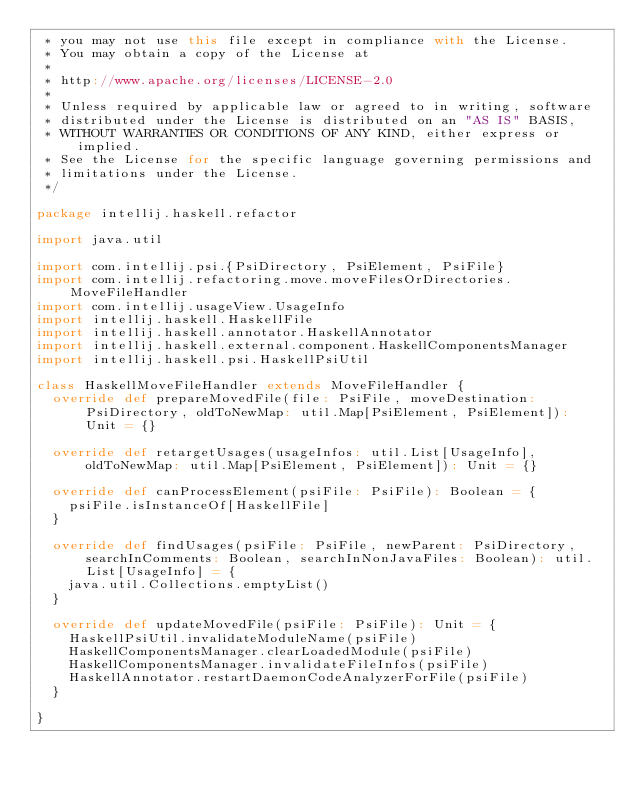<code> <loc_0><loc_0><loc_500><loc_500><_Scala_> * you may not use this file except in compliance with the License.
 * You may obtain a copy of the License at
 *
 * http://www.apache.org/licenses/LICENSE-2.0
 *
 * Unless required by applicable law or agreed to in writing, software
 * distributed under the License is distributed on an "AS IS" BASIS,
 * WITHOUT WARRANTIES OR CONDITIONS OF ANY KIND, either express or implied.
 * See the License for the specific language governing permissions and
 * limitations under the License.
 */

package intellij.haskell.refactor

import java.util

import com.intellij.psi.{PsiDirectory, PsiElement, PsiFile}
import com.intellij.refactoring.move.moveFilesOrDirectories.MoveFileHandler
import com.intellij.usageView.UsageInfo
import intellij.haskell.HaskellFile
import intellij.haskell.annotator.HaskellAnnotator
import intellij.haskell.external.component.HaskellComponentsManager
import intellij.haskell.psi.HaskellPsiUtil

class HaskellMoveFileHandler extends MoveFileHandler {
  override def prepareMovedFile(file: PsiFile, moveDestination: PsiDirectory, oldToNewMap: util.Map[PsiElement, PsiElement]): Unit = {}

  override def retargetUsages(usageInfos: util.List[UsageInfo], oldToNewMap: util.Map[PsiElement, PsiElement]): Unit = {}

  override def canProcessElement(psiFile: PsiFile): Boolean = {
    psiFile.isInstanceOf[HaskellFile]
  }

  override def findUsages(psiFile: PsiFile, newParent: PsiDirectory, searchInComments: Boolean, searchInNonJavaFiles: Boolean): util.List[UsageInfo] = {
    java.util.Collections.emptyList()
  }

  override def updateMovedFile(psiFile: PsiFile): Unit = {
    HaskellPsiUtil.invalidateModuleName(psiFile)
    HaskellComponentsManager.clearLoadedModule(psiFile)
    HaskellComponentsManager.invalidateFileInfos(psiFile)
    HaskellAnnotator.restartDaemonCodeAnalyzerForFile(psiFile)
  }

}</code> 